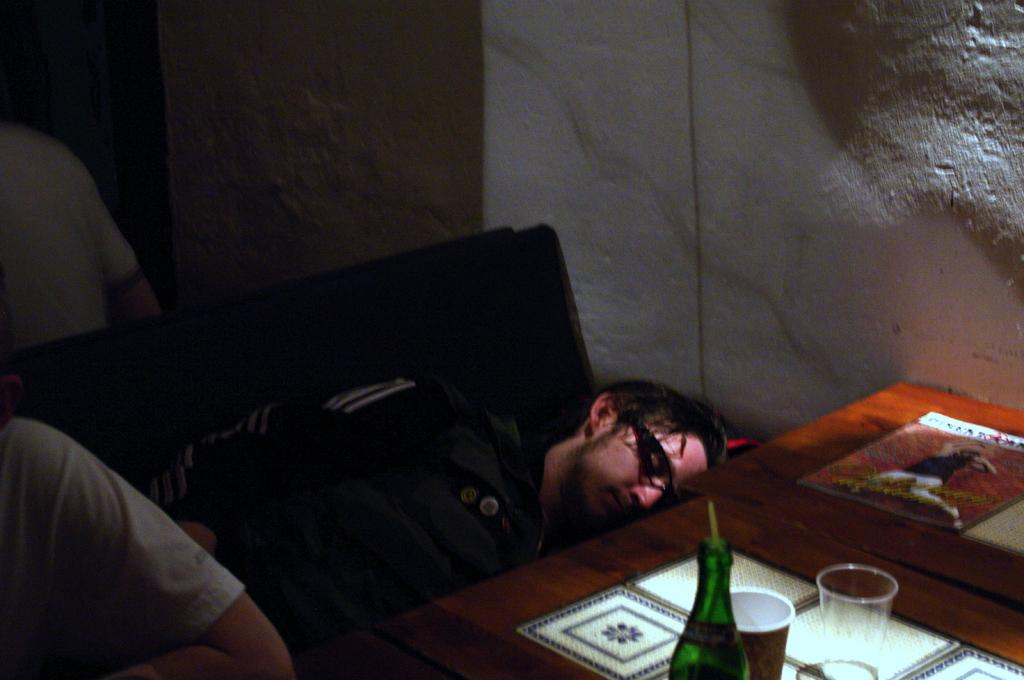What is the man in the image doing? The man is sleeping in the image. Who is near the sleeping man? There is a person beside the sleeping man. What is in front of the man and the person? There is a table in front of the man and the person. What objects can be seen on the table? There is a glass, a bottle, and a book on the table. What can be seen in the background of the image? There is a wall visible in the background of the image. What type of cushion is the man using to sleep in the image? There is no cushion mentioned or visible in the image; the man is simply sleeping. What kind of celery can be seen growing on the wall in the background? There is no celery present in the image; only a wall is visible in the background. 